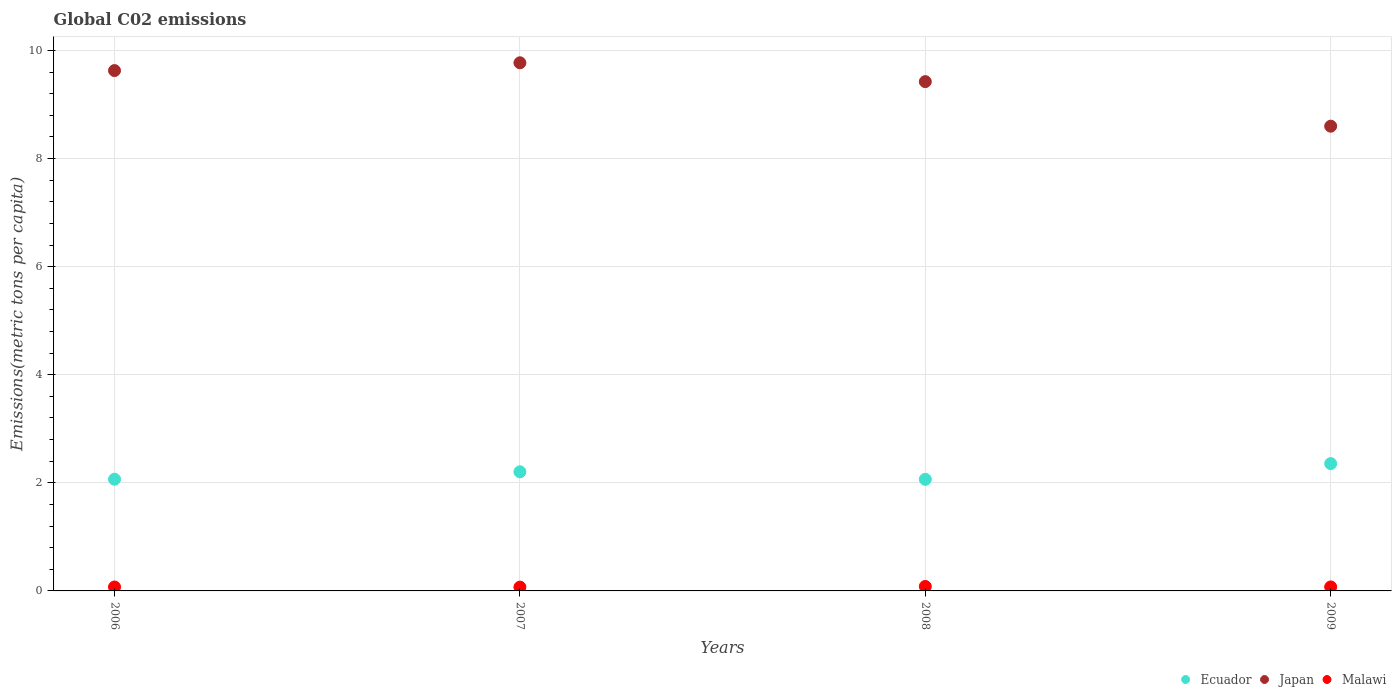Is the number of dotlines equal to the number of legend labels?
Your response must be concise. Yes. What is the amount of CO2 emitted in in Malawi in 2006?
Provide a short and direct response. 0.07. Across all years, what is the maximum amount of CO2 emitted in in Malawi?
Give a very brief answer. 0.08. Across all years, what is the minimum amount of CO2 emitted in in Malawi?
Provide a short and direct response. 0.07. What is the total amount of CO2 emitted in in Japan in the graph?
Offer a terse response. 37.42. What is the difference between the amount of CO2 emitted in in Malawi in 2007 and that in 2008?
Make the answer very short. -0.01. What is the difference between the amount of CO2 emitted in in Malawi in 2006 and the amount of CO2 emitted in in Ecuador in 2009?
Give a very brief answer. -2.28. What is the average amount of CO2 emitted in in Ecuador per year?
Give a very brief answer. 2.17. In the year 2008, what is the difference between the amount of CO2 emitted in in Japan and amount of CO2 emitted in in Malawi?
Your response must be concise. 9.34. In how many years, is the amount of CO2 emitted in in Malawi greater than 0.4 metric tons per capita?
Provide a short and direct response. 0. What is the ratio of the amount of CO2 emitted in in Japan in 2006 to that in 2009?
Make the answer very short. 1.12. Is the amount of CO2 emitted in in Ecuador in 2006 less than that in 2007?
Give a very brief answer. Yes. What is the difference between the highest and the second highest amount of CO2 emitted in in Malawi?
Keep it short and to the point. 0.01. What is the difference between the highest and the lowest amount of CO2 emitted in in Japan?
Your response must be concise. 1.17. In how many years, is the amount of CO2 emitted in in Malawi greater than the average amount of CO2 emitted in in Malawi taken over all years?
Make the answer very short. 1. Is it the case that in every year, the sum of the amount of CO2 emitted in in Malawi and amount of CO2 emitted in in Ecuador  is greater than the amount of CO2 emitted in in Japan?
Offer a very short reply. No. Is the amount of CO2 emitted in in Japan strictly greater than the amount of CO2 emitted in in Malawi over the years?
Offer a terse response. Yes. Is the amount of CO2 emitted in in Malawi strictly less than the amount of CO2 emitted in in Japan over the years?
Offer a very short reply. Yes. How many years are there in the graph?
Make the answer very short. 4. Are the values on the major ticks of Y-axis written in scientific E-notation?
Make the answer very short. No. How many legend labels are there?
Offer a terse response. 3. How are the legend labels stacked?
Make the answer very short. Horizontal. What is the title of the graph?
Give a very brief answer. Global C02 emissions. What is the label or title of the X-axis?
Your answer should be compact. Years. What is the label or title of the Y-axis?
Make the answer very short. Emissions(metric tons per capita). What is the Emissions(metric tons per capita) in Ecuador in 2006?
Ensure brevity in your answer.  2.07. What is the Emissions(metric tons per capita) in Japan in 2006?
Your answer should be compact. 9.63. What is the Emissions(metric tons per capita) in Malawi in 2006?
Offer a terse response. 0.07. What is the Emissions(metric tons per capita) of Ecuador in 2007?
Give a very brief answer. 2.2. What is the Emissions(metric tons per capita) of Japan in 2007?
Provide a succinct answer. 9.77. What is the Emissions(metric tons per capita) in Malawi in 2007?
Provide a short and direct response. 0.07. What is the Emissions(metric tons per capita) in Ecuador in 2008?
Keep it short and to the point. 2.06. What is the Emissions(metric tons per capita) in Japan in 2008?
Offer a terse response. 9.42. What is the Emissions(metric tons per capita) of Malawi in 2008?
Provide a short and direct response. 0.08. What is the Emissions(metric tons per capita) of Ecuador in 2009?
Your response must be concise. 2.36. What is the Emissions(metric tons per capita) of Japan in 2009?
Your response must be concise. 8.6. What is the Emissions(metric tons per capita) in Malawi in 2009?
Your answer should be compact. 0.07. Across all years, what is the maximum Emissions(metric tons per capita) in Ecuador?
Provide a short and direct response. 2.36. Across all years, what is the maximum Emissions(metric tons per capita) in Japan?
Offer a very short reply. 9.77. Across all years, what is the maximum Emissions(metric tons per capita) of Malawi?
Make the answer very short. 0.08. Across all years, what is the minimum Emissions(metric tons per capita) in Ecuador?
Make the answer very short. 2.06. Across all years, what is the minimum Emissions(metric tons per capita) of Japan?
Your answer should be compact. 8.6. Across all years, what is the minimum Emissions(metric tons per capita) in Malawi?
Keep it short and to the point. 0.07. What is the total Emissions(metric tons per capita) of Ecuador in the graph?
Offer a very short reply. 8.69. What is the total Emissions(metric tons per capita) of Japan in the graph?
Your response must be concise. 37.42. What is the total Emissions(metric tons per capita) of Malawi in the graph?
Your response must be concise. 0.3. What is the difference between the Emissions(metric tons per capita) in Ecuador in 2006 and that in 2007?
Keep it short and to the point. -0.14. What is the difference between the Emissions(metric tons per capita) of Japan in 2006 and that in 2007?
Give a very brief answer. -0.14. What is the difference between the Emissions(metric tons per capita) in Malawi in 2006 and that in 2007?
Your response must be concise. 0. What is the difference between the Emissions(metric tons per capita) in Ecuador in 2006 and that in 2008?
Your answer should be very brief. 0. What is the difference between the Emissions(metric tons per capita) of Japan in 2006 and that in 2008?
Offer a very short reply. 0.2. What is the difference between the Emissions(metric tons per capita) of Malawi in 2006 and that in 2008?
Provide a short and direct response. -0.01. What is the difference between the Emissions(metric tons per capita) in Ecuador in 2006 and that in 2009?
Ensure brevity in your answer.  -0.29. What is the difference between the Emissions(metric tons per capita) of Japan in 2006 and that in 2009?
Provide a succinct answer. 1.03. What is the difference between the Emissions(metric tons per capita) in Malawi in 2006 and that in 2009?
Your answer should be very brief. -0. What is the difference between the Emissions(metric tons per capita) in Ecuador in 2007 and that in 2008?
Your answer should be very brief. 0.14. What is the difference between the Emissions(metric tons per capita) in Japan in 2007 and that in 2008?
Provide a short and direct response. 0.35. What is the difference between the Emissions(metric tons per capita) in Malawi in 2007 and that in 2008?
Provide a succinct answer. -0.01. What is the difference between the Emissions(metric tons per capita) of Ecuador in 2007 and that in 2009?
Your answer should be very brief. -0.15. What is the difference between the Emissions(metric tons per capita) in Japan in 2007 and that in 2009?
Your response must be concise. 1.17. What is the difference between the Emissions(metric tons per capita) in Malawi in 2007 and that in 2009?
Your answer should be very brief. -0. What is the difference between the Emissions(metric tons per capita) of Ecuador in 2008 and that in 2009?
Give a very brief answer. -0.29. What is the difference between the Emissions(metric tons per capita) in Japan in 2008 and that in 2009?
Give a very brief answer. 0.82. What is the difference between the Emissions(metric tons per capita) of Malawi in 2008 and that in 2009?
Keep it short and to the point. 0.01. What is the difference between the Emissions(metric tons per capita) of Ecuador in 2006 and the Emissions(metric tons per capita) of Japan in 2007?
Provide a short and direct response. -7.71. What is the difference between the Emissions(metric tons per capita) of Ecuador in 2006 and the Emissions(metric tons per capita) of Malawi in 2007?
Provide a succinct answer. 2. What is the difference between the Emissions(metric tons per capita) in Japan in 2006 and the Emissions(metric tons per capita) in Malawi in 2007?
Your response must be concise. 9.56. What is the difference between the Emissions(metric tons per capita) of Ecuador in 2006 and the Emissions(metric tons per capita) of Japan in 2008?
Ensure brevity in your answer.  -7.36. What is the difference between the Emissions(metric tons per capita) of Ecuador in 2006 and the Emissions(metric tons per capita) of Malawi in 2008?
Ensure brevity in your answer.  1.98. What is the difference between the Emissions(metric tons per capita) in Japan in 2006 and the Emissions(metric tons per capita) in Malawi in 2008?
Offer a terse response. 9.54. What is the difference between the Emissions(metric tons per capita) of Ecuador in 2006 and the Emissions(metric tons per capita) of Japan in 2009?
Your response must be concise. -6.53. What is the difference between the Emissions(metric tons per capita) in Ecuador in 2006 and the Emissions(metric tons per capita) in Malawi in 2009?
Ensure brevity in your answer.  1.99. What is the difference between the Emissions(metric tons per capita) of Japan in 2006 and the Emissions(metric tons per capita) of Malawi in 2009?
Provide a succinct answer. 9.55. What is the difference between the Emissions(metric tons per capita) of Ecuador in 2007 and the Emissions(metric tons per capita) of Japan in 2008?
Your answer should be very brief. -7.22. What is the difference between the Emissions(metric tons per capita) in Ecuador in 2007 and the Emissions(metric tons per capita) in Malawi in 2008?
Offer a terse response. 2.12. What is the difference between the Emissions(metric tons per capita) of Japan in 2007 and the Emissions(metric tons per capita) of Malawi in 2008?
Make the answer very short. 9.69. What is the difference between the Emissions(metric tons per capita) of Ecuador in 2007 and the Emissions(metric tons per capita) of Japan in 2009?
Give a very brief answer. -6.39. What is the difference between the Emissions(metric tons per capita) in Ecuador in 2007 and the Emissions(metric tons per capita) in Malawi in 2009?
Ensure brevity in your answer.  2.13. What is the difference between the Emissions(metric tons per capita) in Japan in 2007 and the Emissions(metric tons per capita) in Malawi in 2009?
Make the answer very short. 9.7. What is the difference between the Emissions(metric tons per capita) of Ecuador in 2008 and the Emissions(metric tons per capita) of Japan in 2009?
Your answer should be compact. -6.53. What is the difference between the Emissions(metric tons per capita) in Ecuador in 2008 and the Emissions(metric tons per capita) in Malawi in 2009?
Make the answer very short. 1.99. What is the difference between the Emissions(metric tons per capita) of Japan in 2008 and the Emissions(metric tons per capita) of Malawi in 2009?
Ensure brevity in your answer.  9.35. What is the average Emissions(metric tons per capita) in Ecuador per year?
Make the answer very short. 2.17. What is the average Emissions(metric tons per capita) in Japan per year?
Ensure brevity in your answer.  9.36. What is the average Emissions(metric tons per capita) of Malawi per year?
Your response must be concise. 0.07. In the year 2006, what is the difference between the Emissions(metric tons per capita) of Ecuador and Emissions(metric tons per capita) of Japan?
Make the answer very short. -7.56. In the year 2006, what is the difference between the Emissions(metric tons per capita) in Ecuador and Emissions(metric tons per capita) in Malawi?
Provide a succinct answer. 1.99. In the year 2006, what is the difference between the Emissions(metric tons per capita) in Japan and Emissions(metric tons per capita) in Malawi?
Your answer should be very brief. 9.55. In the year 2007, what is the difference between the Emissions(metric tons per capita) of Ecuador and Emissions(metric tons per capita) of Japan?
Offer a very short reply. -7.57. In the year 2007, what is the difference between the Emissions(metric tons per capita) in Ecuador and Emissions(metric tons per capita) in Malawi?
Offer a terse response. 2.13. In the year 2007, what is the difference between the Emissions(metric tons per capita) of Japan and Emissions(metric tons per capita) of Malawi?
Your answer should be very brief. 9.7. In the year 2008, what is the difference between the Emissions(metric tons per capita) of Ecuador and Emissions(metric tons per capita) of Japan?
Ensure brevity in your answer.  -7.36. In the year 2008, what is the difference between the Emissions(metric tons per capita) of Ecuador and Emissions(metric tons per capita) of Malawi?
Give a very brief answer. 1.98. In the year 2008, what is the difference between the Emissions(metric tons per capita) in Japan and Emissions(metric tons per capita) in Malawi?
Provide a short and direct response. 9.34. In the year 2009, what is the difference between the Emissions(metric tons per capita) in Ecuador and Emissions(metric tons per capita) in Japan?
Provide a short and direct response. -6.24. In the year 2009, what is the difference between the Emissions(metric tons per capita) in Ecuador and Emissions(metric tons per capita) in Malawi?
Your answer should be very brief. 2.28. In the year 2009, what is the difference between the Emissions(metric tons per capita) in Japan and Emissions(metric tons per capita) in Malawi?
Your answer should be compact. 8.52. What is the ratio of the Emissions(metric tons per capita) in Malawi in 2006 to that in 2007?
Ensure brevity in your answer.  1.03. What is the ratio of the Emissions(metric tons per capita) of Ecuador in 2006 to that in 2008?
Keep it short and to the point. 1. What is the ratio of the Emissions(metric tons per capita) of Japan in 2006 to that in 2008?
Your answer should be compact. 1.02. What is the ratio of the Emissions(metric tons per capita) of Malawi in 2006 to that in 2008?
Provide a short and direct response. 0.88. What is the ratio of the Emissions(metric tons per capita) in Ecuador in 2006 to that in 2009?
Your response must be concise. 0.88. What is the ratio of the Emissions(metric tons per capita) of Japan in 2006 to that in 2009?
Your answer should be compact. 1.12. What is the ratio of the Emissions(metric tons per capita) in Malawi in 2006 to that in 2009?
Give a very brief answer. 0.99. What is the ratio of the Emissions(metric tons per capita) of Ecuador in 2007 to that in 2008?
Keep it short and to the point. 1.07. What is the ratio of the Emissions(metric tons per capita) of Malawi in 2007 to that in 2008?
Your response must be concise. 0.86. What is the ratio of the Emissions(metric tons per capita) in Ecuador in 2007 to that in 2009?
Your answer should be compact. 0.94. What is the ratio of the Emissions(metric tons per capita) of Japan in 2007 to that in 2009?
Ensure brevity in your answer.  1.14. What is the ratio of the Emissions(metric tons per capita) of Malawi in 2007 to that in 2009?
Ensure brevity in your answer.  0.96. What is the ratio of the Emissions(metric tons per capita) of Ecuador in 2008 to that in 2009?
Keep it short and to the point. 0.88. What is the ratio of the Emissions(metric tons per capita) in Japan in 2008 to that in 2009?
Ensure brevity in your answer.  1.1. What is the ratio of the Emissions(metric tons per capita) in Malawi in 2008 to that in 2009?
Your answer should be compact. 1.12. What is the difference between the highest and the second highest Emissions(metric tons per capita) of Ecuador?
Provide a succinct answer. 0.15. What is the difference between the highest and the second highest Emissions(metric tons per capita) of Japan?
Make the answer very short. 0.14. What is the difference between the highest and the second highest Emissions(metric tons per capita) of Malawi?
Offer a very short reply. 0.01. What is the difference between the highest and the lowest Emissions(metric tons per capita) in Ecuador?
Your answer should be compact. 0.29. What is the difference between the highest and the lowest Emissions(metric tons per capita) of Japan?
Make the answer very short. 1.17. What is the difference between the highest and the lowest Emissions(metric tons per capita) in Malawi?
Provide a short and direct response. 0.01. 